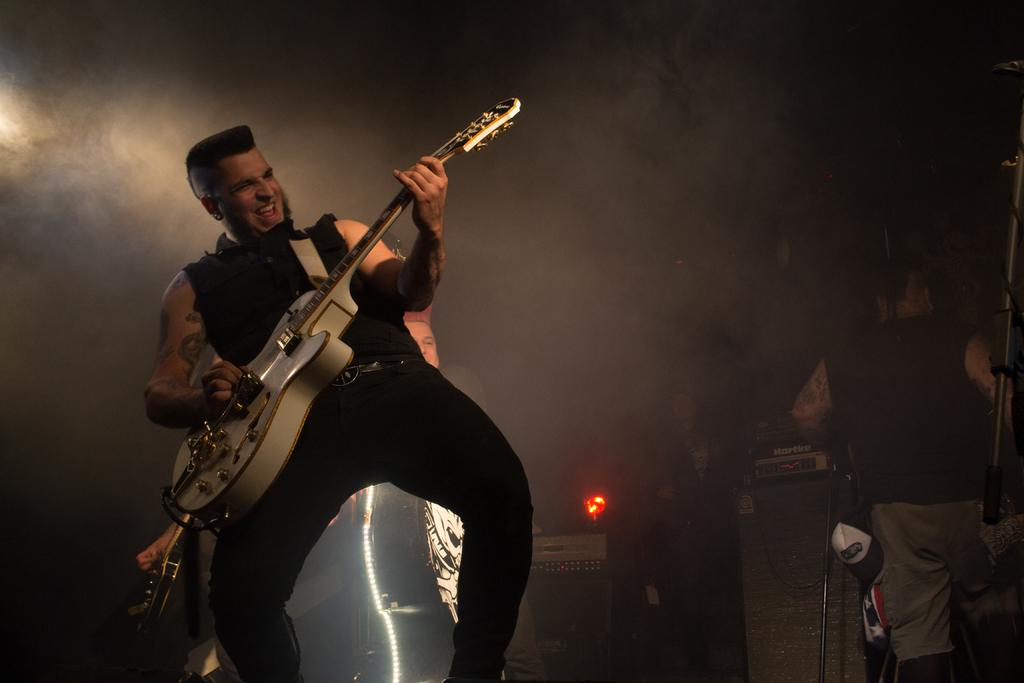What is the man in the image doing? The man is playing a guitar in the image. Are there any other people in the image besides the man playing the guitar? Yes, there are people standing behind the man in the image. Can you describe the lighting in the image? There is a light visible in the image. What type of hose is being used to water the plants in the image? There is no hose or plants present in the image; it features a man playing a guitar with people standing behind him and a visible light. 